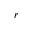Convert formula to latex. <formula><loc_0><loc_0><loc_500><loc_500>r</formula> 